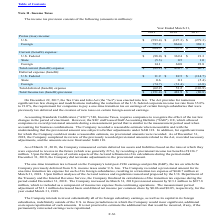According to Microchip Technology's financial document, Which legislation was enacted into law on December 22, 2017? the Tax Cuts and Jobs Act. The document states: "On December 22, 2017, the Tax Cuts and Jobs Act (the "Act") was enacted into law. The Act provides for numerous..." Also, What was the pretax (loss) income for the U.S. in 2019? According to the financial document, (593.4) (in millions). The relevant text states: "U.S. $ (593.4) $ (127.3) $ (279.3)..." Also, Which years does the table provide information for the company's income tax provision? The document contains multiple relevant values: 2019, 2018, 2017. From the document: "2019 2018 2017 2019 2018 2017 2019 2018 2017..." Also, can you calculate: What was the change in the Deferred expense for State between 2018 and 2019? Based on the calculation: 0.6-0.1, the result is 0.5 (in millions). This is based on the information: "State 0.6 0.1 (5.4) State 0.6 0.1 (5.4)..." The key data points involved are: 0.1, 0.6. Also, can you calculate: What was the change in the Foreign Pretax income between 2018 and 2019?  Based on the calculation: 797.9-864.6, the result is -66.7 (in millions). This is based on the information: "Foreign 797.9 864.6 369.1 Foreign 797.9 864.6 369.1..." The key data points involved are: 797.9, 864.6. Also, can you calculate: What was the percentage change in the Total current expense between 2017 and 2018? To answer this question, I need to perform calculations using the financial data. The calculation is: (430.7-46.1)/46.1, which equals 834.27 (percentage). This is based on the information: "Total current (benefit) expense $ (89.2) $ 430.7 $ 46.1 otal current (benefit) expense $ (89.2) $ 430.7 $ 46.1..." The key data points involved are: 430.7, 46.1. 